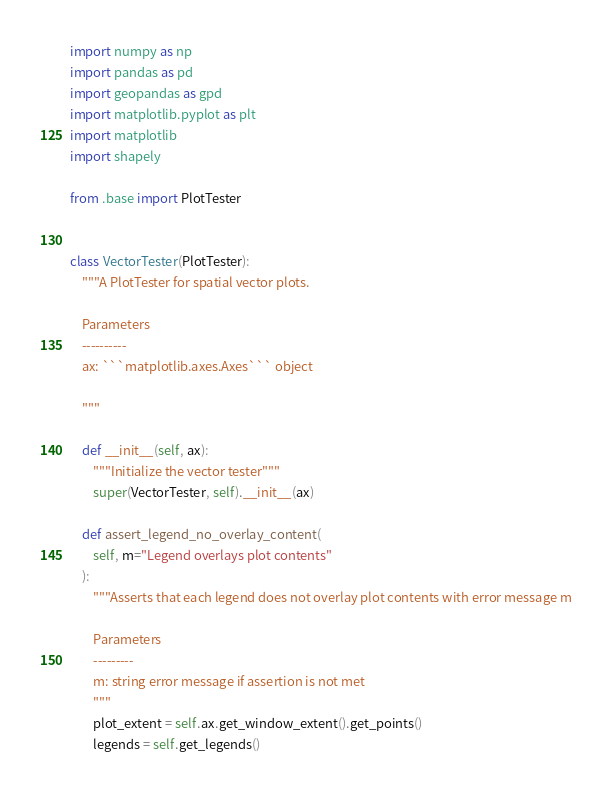Convert code to text. <code><loc_0><loc_0><loc_500><loc_500><_Python_>import numpy as np
import pandas as pd
import geopandas as gpd
import matplotlib.pyplot as plt
import matplotlib
import shapely

from .base import PlotTester


class VectorTester(PlotTester):
    """A PlotTester for spatial vector plots.

	Parameters
	----------
	ax: ```matplotlib.axes.Axes``` object

	"""

    def __init__(self, ax):
        """Initialize the vector tester"""
        super(VectorTester, self).__init__(ax)

    def assert_legend_no_overlay_content(
        self, m="Legend overlays plot contents"
    ):
        """Asserts that each legend does not overlay plot contents with error message m

		Parameters
		---------
		m: string error message if assertion is not met
		"""
        plot_extent = self.ax.get_window_extent().get_points()
        legends = self.get_legends()</code> 